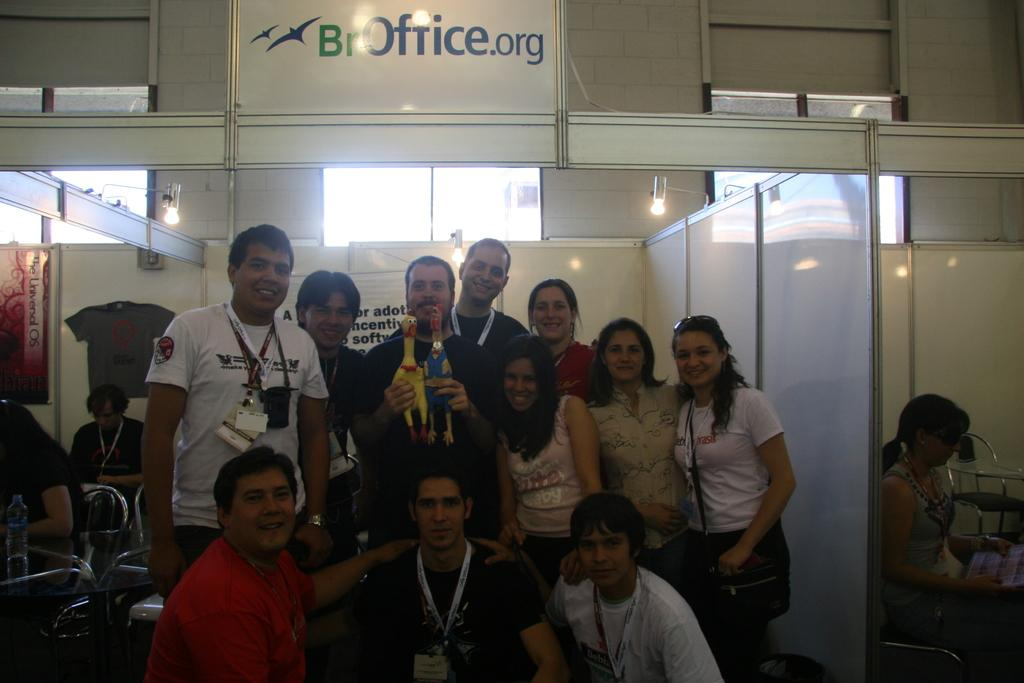What types of people are in the image? There are men and women in the image. Where are the men and women located in the image? The men and women are standing in the middle of the image. What can be seen around the necks of the people in the image? The people have id cards around their necks. What is above the people in the image? There are lights above the people. What architectural feature can be seen in the background of the image? There are windows on the wall in the background of the image. What type of knife is being used to develop the cellar in the image? There is no knife or cellar present in the image; it features men and women standing with id cards around their necks. 